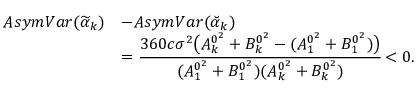Convert formula to latex. <formula><loc_0><loc_0><loc_500><loc_500>\begin{array} { r l } { A s y m V a r ( \widetilde { \alpha } _ { k } ) } & { - A s y m V a r ( \breve { \alpha } _ { k } ) } \\ & { = \cfrac { 3 6 0 c \sigma ^ { 2 } \left ( A _ { k } ^ { 0 ^ { 2 } } + B _ { k } ^ { 0 ^ { 2 } } - ( A _ { 1 } ^ { 0 ^ { 2 } } + B _ { 1 } ^ { 0 ^ { 2 } } ) \right ) } { ( A _ { 1 } ^ { 0 ^ { 2 } } + B _ { 1 } ^ { 0 ^ { 2 } } ) ( A _ { k } ^ { 0 ^ { 2 } } + B _ { k } ^ { 0 ^ { 2 } } ) } < 0 . } \end{array}</formula> 